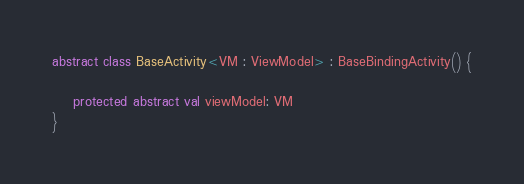Convert code to text. <code><loc_0><loc_0><loc_500><loc_500><_Kotlin_>
abstract class BaseActivity<VM : ViewModel> : BaseBindingActivity() {

    protected abstract val viewModel: VM
}</code> 